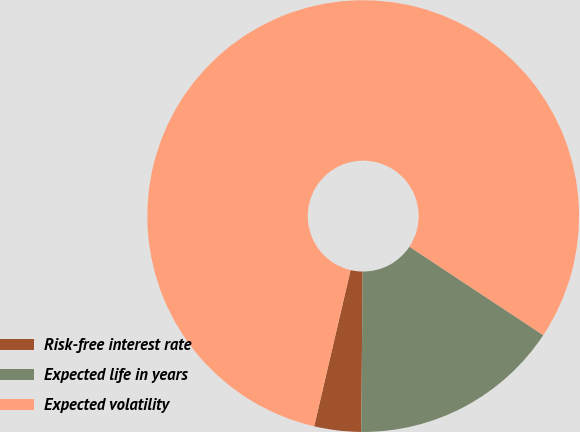Convert chart to OTSL. <chart><loc_0><loc_0><loc_500><loc_500><pie_chart><fcel>Risk-free interest rate<fcel>Expected life in years<fcel>Expected volatility<nl><fcel>3.5%<fcel>15.85%<fcel>80.65%<nl></chart> 